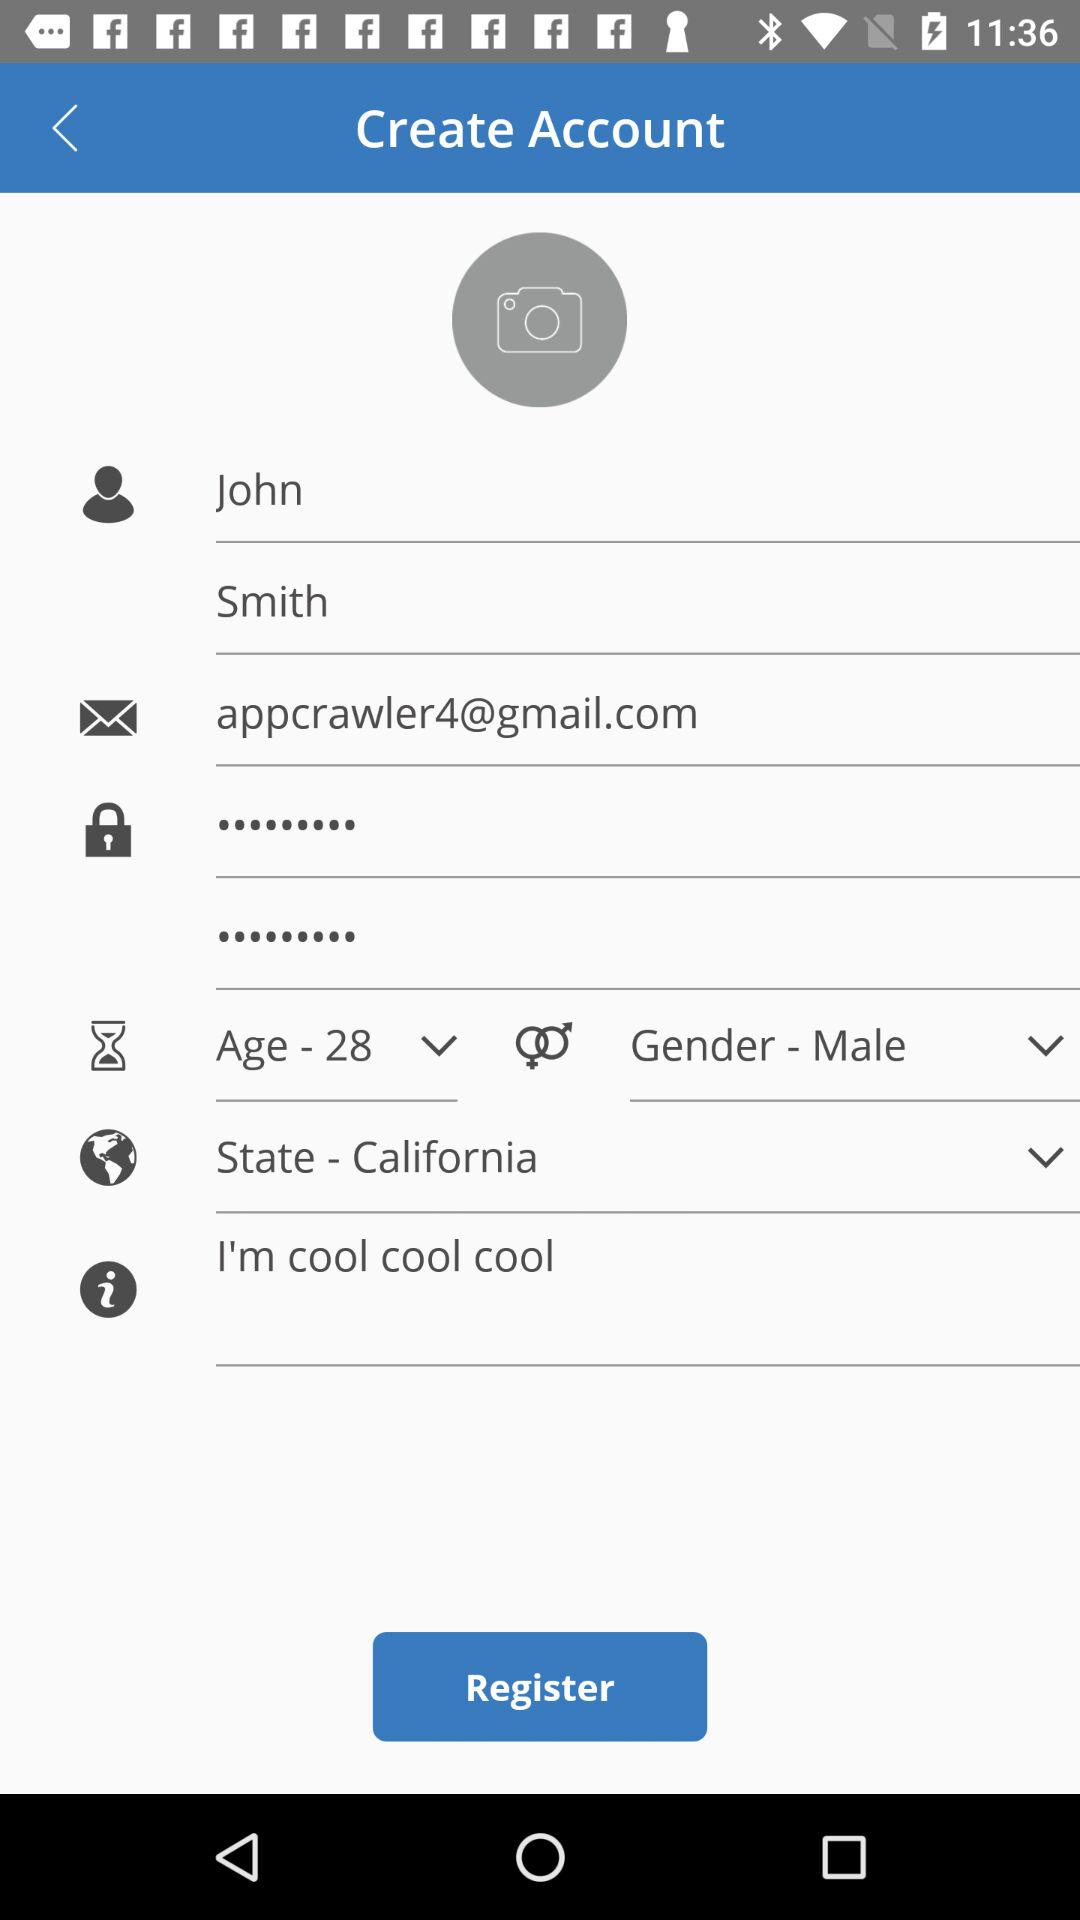What is age of John Smith? John Smith is 28 years old. 